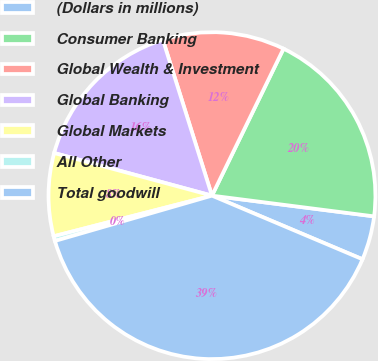Convert chart to OTSL. <chart><loc_0><loc_0><loc_500><loc_500><pie_chart><fcel>(Dollars in millions)<fcel>Consumer Banking<fcel>Global Wealth & Investment<fcel>Global Banking<fcel>Global Markets<fcel>All Other<fcel>Total goodwill<nl><fcel>4.34%<fcel>19.81%<fcel>12.07%<fcel>15.94%<fcel>8.2%<fcel>0.47%<fcel>39.16%<nl></chart> 